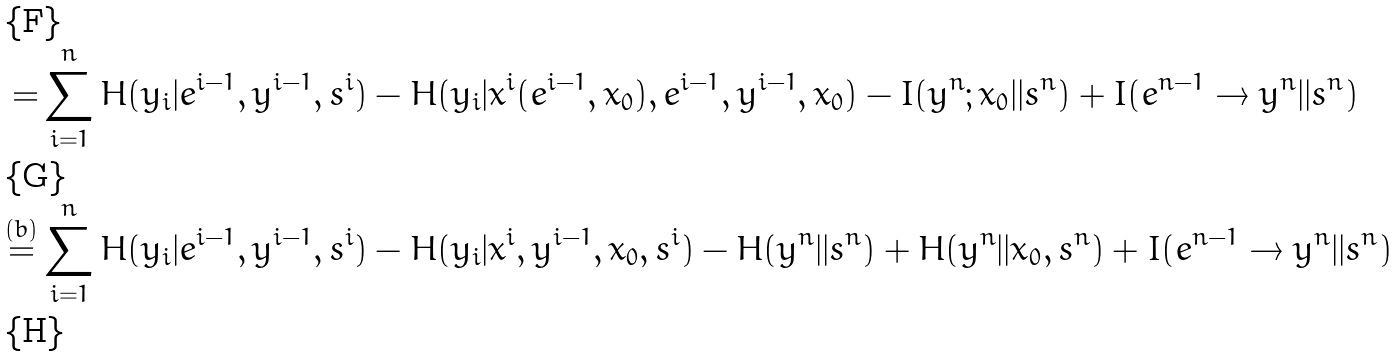Convert formula to latex. <formula><loc_0><loc_0><loc_500><loc_500>= & \sum _ { i = 1 } ^ { n } H ( y _ { i } | e ^ { i - 1 } , y ^ { i - 1 } , s ^ { i } ) - H ( y _ { i } | x ^ { i } ( e ^ { i - 1 } , x _ { 0 } ) , e ^ { i - 1 } , y ^ { i - 1 } , x _ { 0 } ) - I ( y ^ { n } ; x _ { 0 } | | s ^ { n } ) + I ( e ^ { n - 1 } \rightarrow y ^ { n } | | s ^ { n } ) \\ \stackrel { ( b ) } = & \sum _ { i = 1 } ^ { n } H ( y _ { i } | e ^ { i - 1 } , y ^ { i - 1 } , s ^ { i } ) - H ( y _ { i } | x ^ { i } , y ^ { i - 1 } , x _ { 0 } , s ^ { i } ) - H ( y ^ { n } | | s ^ { n } ) + H ( y ^ { n } | | x _ { 0 } , s ^ { n } ) + I ( e ^ { n - 1 } \rightarrow y ^ { n } | | s ^ { n } ) \\</formula> 